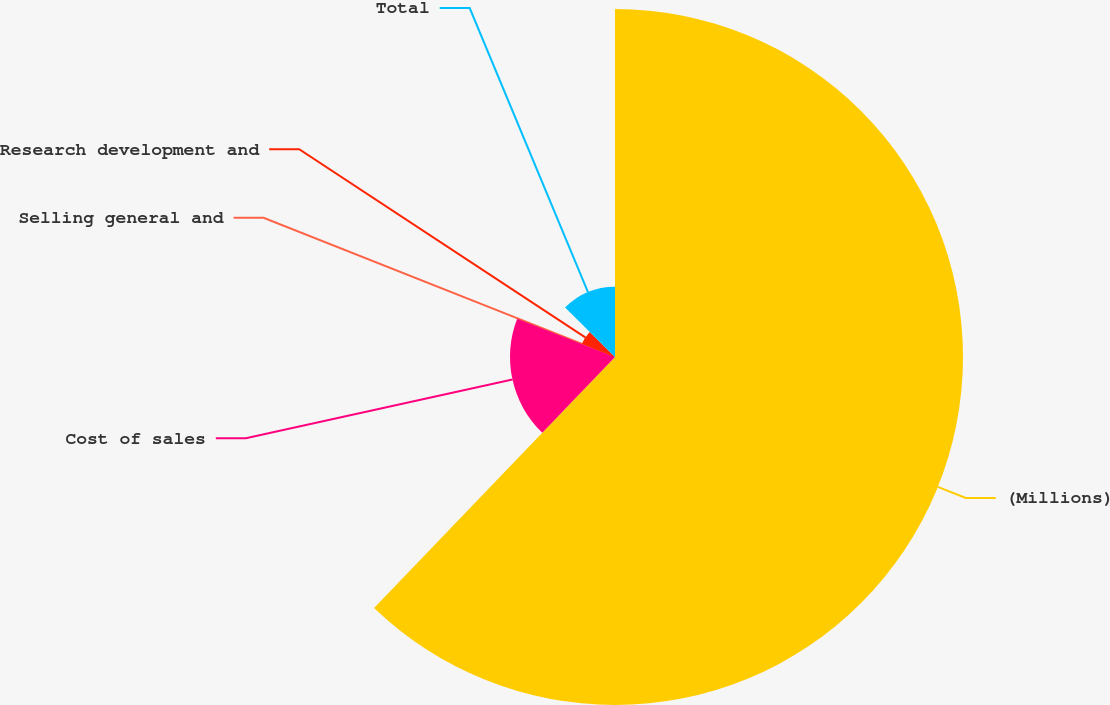Convert chart. <chart><loc_0><loc_0><loc_500><loc_500><pie_chart><fcel>(Millions)<fcel>Cost of sales<fcel>Selling general and<fcel>Research development and<fcel>Total<nl><fcel>62.17%<fcel>18.76%<fcel>0.15%<fcel>6.36%<fcel>12.56%<nl></chart> 